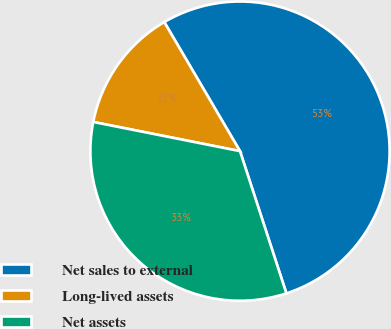Convert chart. <chart><loc_0><loc_0><loc_500><loc_500><pie_chart><fcel>Net sales to external<fcel>Long-lived assets<fcel>Net assets<nl><fcel>53.43%<fcel>13.43%<fcel>33.14%<nl></chart> 